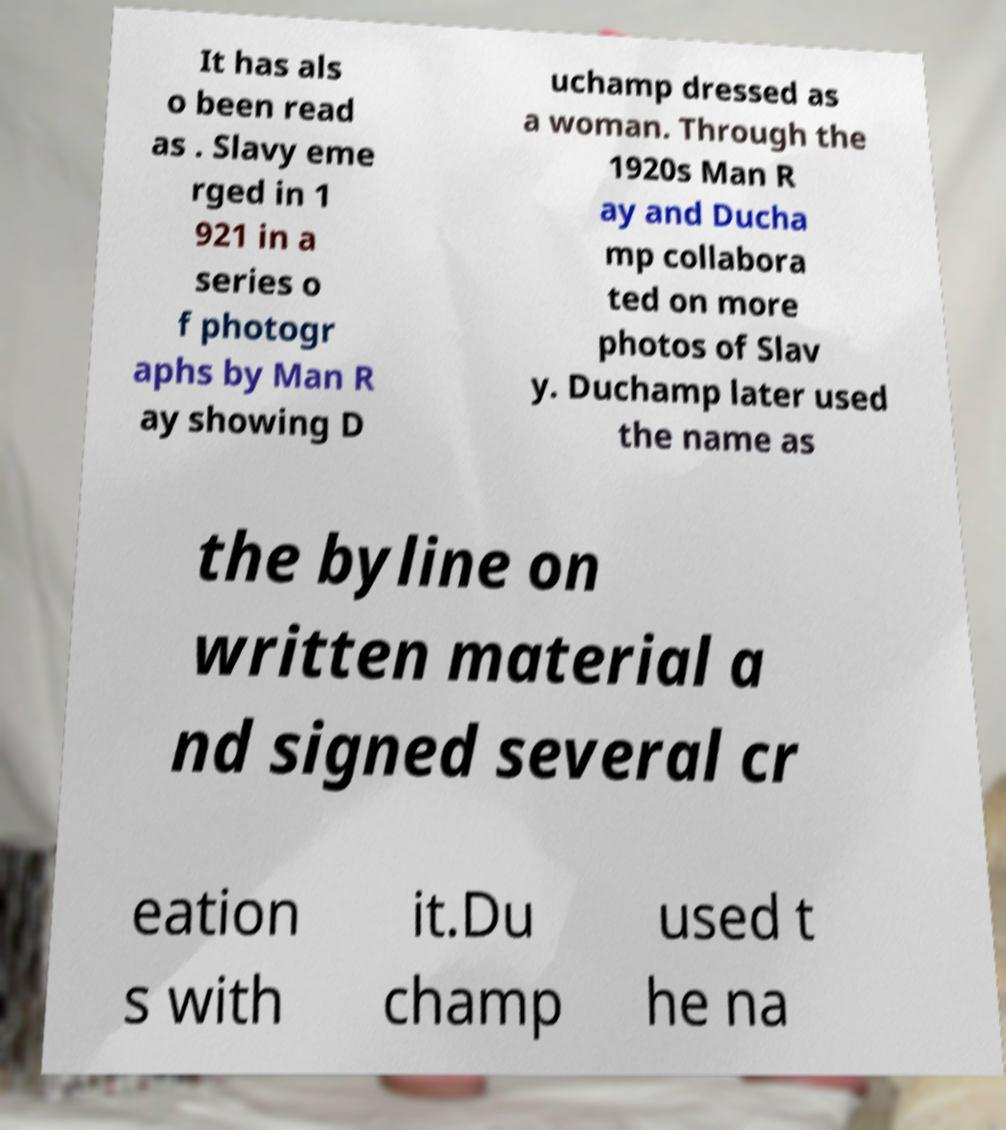I need the written content from this picture converted into text. Can you do that? It has als o been read as . Slavy eme rged in 1 921 in a series o f photogr aphs by Man R ay showing D uchamp dressed as a woman. Through the 1920s Man R ay and Ducha mp collabora ted on more photos of Slav y. Duchamp later used the name as the byline on written material a nd signed several cr eation s with it.Du champ used t he na 